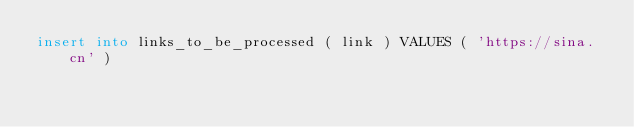<code> <loc_0><loc_0><loc_500><loc_500><_SQL_>insert into links_to_be_processed ( link ) VALUES ( 'https://sina.cn' )</code> 